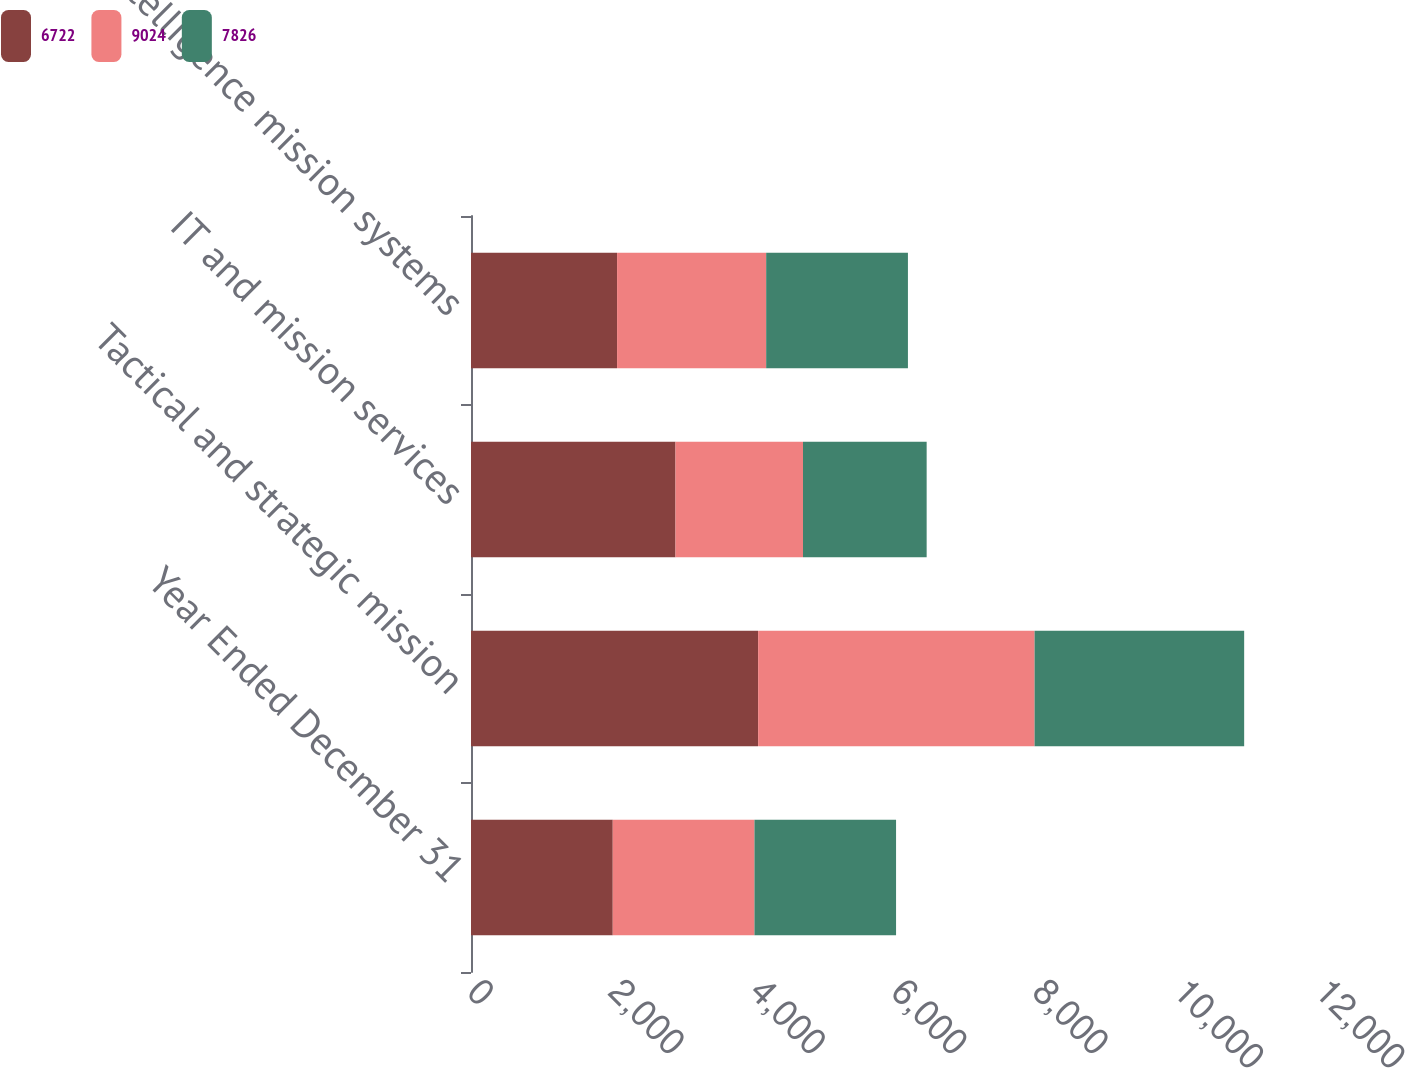Convert chart. <chart><loc_0><loc_0><loc_500><loc_500><stacked_bar_chart><ecel><fcel>Year Ended December 31<fcel>Tactical and strategic mission<fcel>IT and mission services<fcel>Intelligence mission systems<nl><fcel>6722<fcel>2006<fcel>4063<fcel>2894<fcel>2067<nl><fcel>9024<fcel>2005<fcel>3912<fcel>1804<fcel>2110<nl><fcel>7826<fcel>2004<fcel>2966<fcel>1750<fcel>2006<nl></chart> 